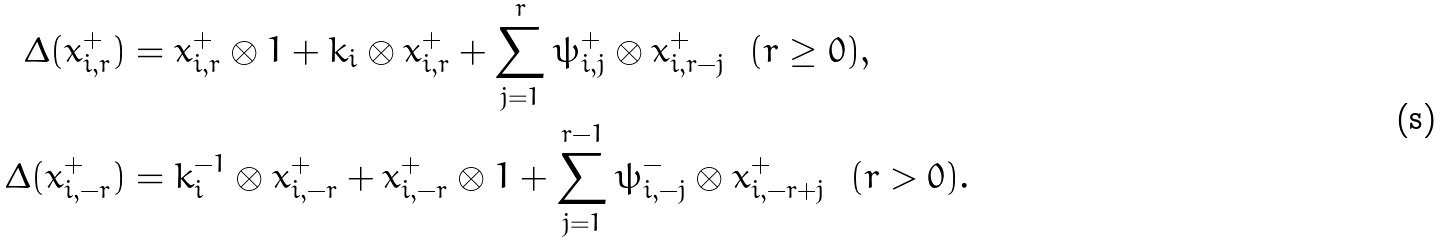<formula> <loc_0><loc_0><loc_500><loc_500>\Delta ( x _ { i , r } ^ { + } ) & = x _ { i , r } ^ { + } \otimes 1 + k _ { i } \otimes x _ { i , r } ^ { + } + \sum _ { j = 1 } ^ { r } \psi ^ { + } _ { i , j } \otimes x _ { i , r - j } ^ { + } \ \ ( r \geq 0 ) , \\ \Delta ( x _ { i , - r } ^ { + } ) & = k _ { i } ^ { - 1 } \otimes x _ { i , - r } ^ { + } + x _ { i , - r } ^ { + } \otimes 1 + \sum _ { j = 1 } ^ { r - 1 } \psi ^ { - } _ { i , - j } \otimes x _ { i , - r + j } ^ { + } \ \ ( r > 0 ) .</formula> 